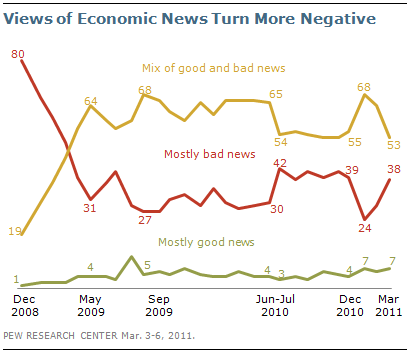Identify some key points in this picture. The difference in value between the highest value of the red line and the lowest value of the green line is 79. The highest value of the orange line is 68. 